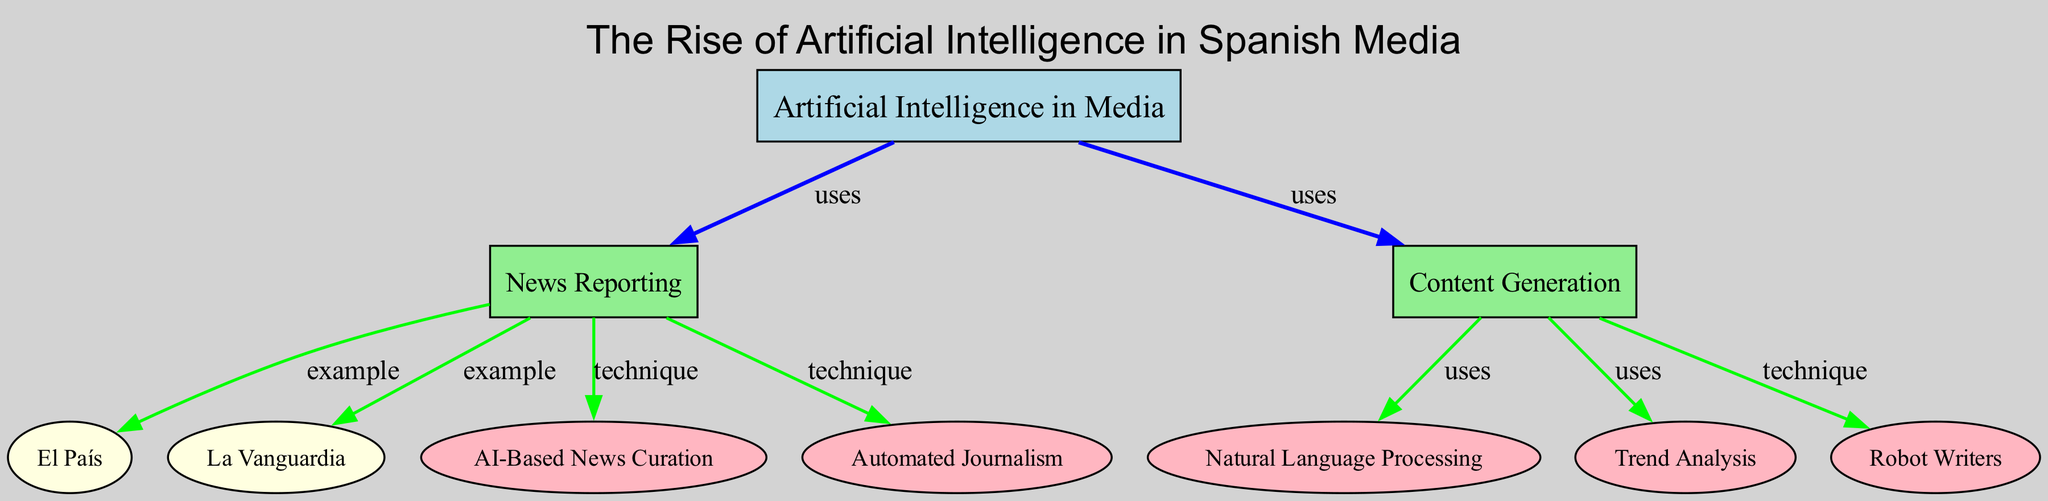What is the main theme of the diagram? The diagram's title is "The Rise of Artificial Intelligence in Spanish Media," which indicates that the main theme is focused on AI applications in the Spanish media landscape.
Answer: The Rise of Artificial Intelligence in Spanish Media How many nodes are present in the diagram? The diagram contains a total of 10 nodes, each representing a unique concept or entity related to the topic.
Answer: 10 Name one example of news reporting in the diagram. The diagram lists "El País" and "La Vanguardia" as examples of news reporting that utilize artificial intelligence.
Answer: El País What technique is associated with automated journalism? The diagram indicates that "Automated Journalism" is linked to "AI-Based News Curation" and "Robot Writers." The technique directly connected to "Automated Journalism" is not explicitly named but relates closely to the usage of AI in content generation.
Answer: AI-Based News Curation Which two types of AI applications are derived from news reporting? The AI applications derived from news reporting include "AI-Based News Curation" and "Automated Journalism." They illustrate how AI is employed within the realm of news reporting.
Answer: AI-Based News Curation, Automated Journalism What does "Natural Language Processing" relate to in the diagram? "Natural Language Processing" is identified as a technique used in content generation, connecting it to the broader category of AI applications mentioned in the diagram.
Answer: Content Generation Which node specifies a technique that utilizes trend analysis? The node "Trend Analysis" is specifically connected to the "Content Generation" node, highlighting its function in generating insights or narratives based on trends in the content market.
Answer: Content Generation How many edges are connected to the "Artificial Intelligence in Media" node? The "Artificial Intelligence in Media" node has two direct edges, indicating its relations to news reporting and content generation in the diagram.
Answer: 2 Which node represents a news outlet that utilizes AI? The nodes "El País" and "La Vanguardia" both represent news outlets utilizing AI, showcasing real-world examples in the Spanish media context.
Answer: El País 